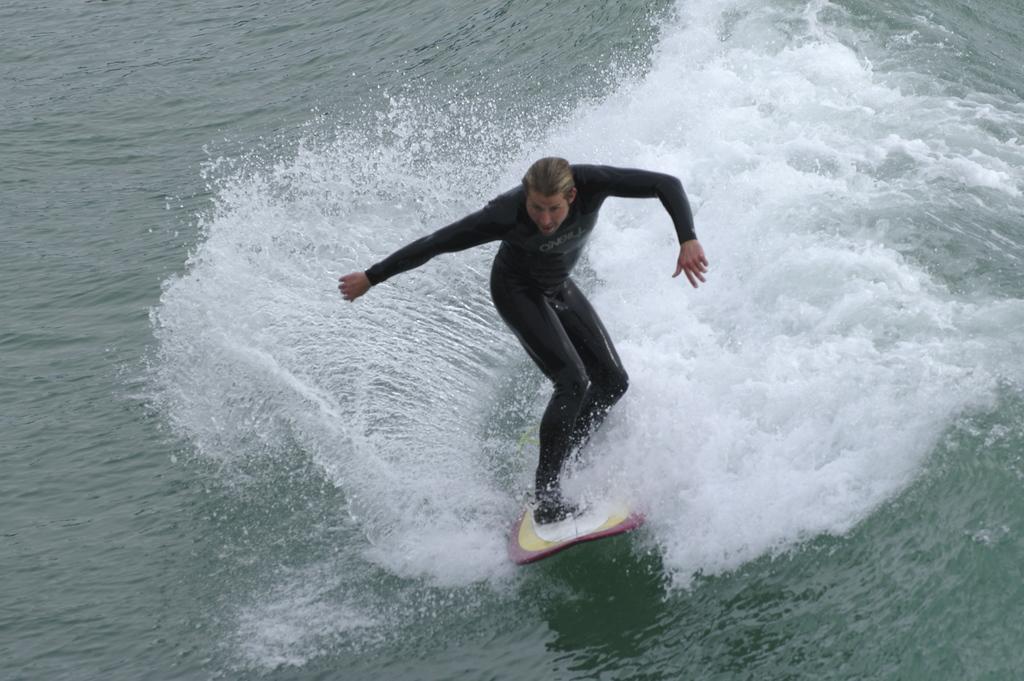Please provide a concise description of this image. In this image I can see a person wearing a black color dress and riding on surfboard in the ocean. 